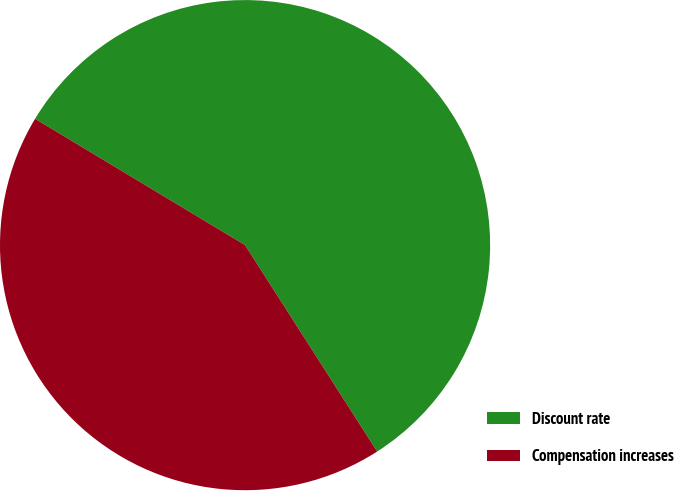<chart> <loc_0><loc_0><loc_500><loc_500><pie_chart><fcel>Discount rate<fcel>Compensation increases<nl><fcel>57.32%<fcel>42.68%<nl></chart> 